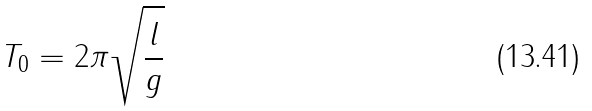<formula> <loc_0><loc_0><loc_500><loc_500>T _ { 0 } = 2 \pi \sqrt { \frac { l } { g } }</formula> 